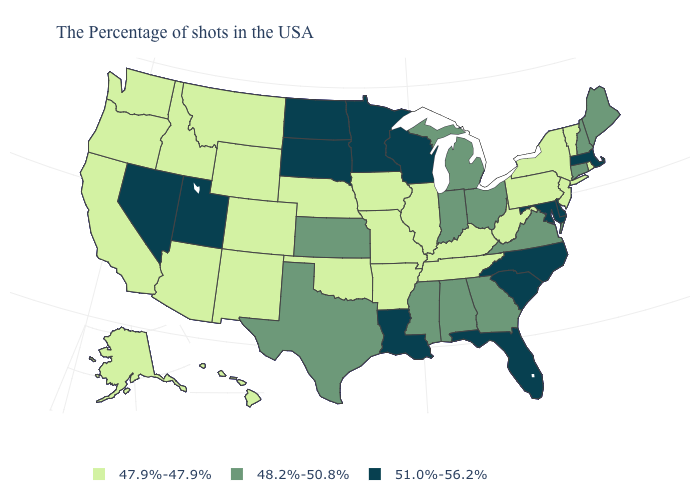Does Massachusetts have the highest value in the Northeast?
Answer briefly. Yes. Name the states that have a value in the range 51.0%-56.2%?
Keep it brief. Massachusetts, Delaware, Maryland, North Carolina, South Carolina, Florida, Wisconsin, Louisiana, Minnesota, South Dakota, North Dakota, Utah, Nevada. What is the highest value in the USA?
Quick response, please. 51.0%-56.2%. What is the value of Hawaii?
Give a very brief answer. 47.9%-47.9%. Which states hav the highest value in the MidWest?
Be succinct. Wisconsin, Minnesota, South Dakota, North Dakota. What is the value of Pennsylvania?
Keep it brief. 47.9%-47.9%. Does the map have missing data?
Short answer required. No. Name the states that have a value in the range 47.9%-47.9%?
Give a very brief answer. Rhode Island, Vermont, New York, New Jersey, Pennsylvania, West Virginia, Kentucky, Tennessee, Illinois, Missouri, Arkansas, Iowa, Nebraska, Oklahoma, Wyoming, Colorado, New Mexico, Montana, Arizona, Idaho, California, Washington, Oregon, Alaska, Hawaii. What is the value of Delaware?
Short answer required. 51.0%-56.2%. What is the highest value in states that border Alabama?
Be succinct. 51.0%-56.2%. Is the legend a continuous bar?
Answer briefly. No. Does the first symbol in the legend represent the smallest category?
Answer briefly. Yes. Name the states that have a value in the range 47.9%-47.9%?
Be succinct. Rhode Island, Vermont, New York, New Jersey, Pennsylvania, West Virginia, Kentucky, Tennessee, Illinois, Missouri, Arkansas, Iowa, Nebraska, Oklahoma, Wyoming, Colorado, New Mexico, Montana, Arizona, Idaho, California, Washington, Oregon, Alaska, Hawaii. What is the lowest value in the West?
Answer briefly. 47.9%-47.9%. What is the value of North Carolina?
Be succinct. 51.0%-56.2%. 